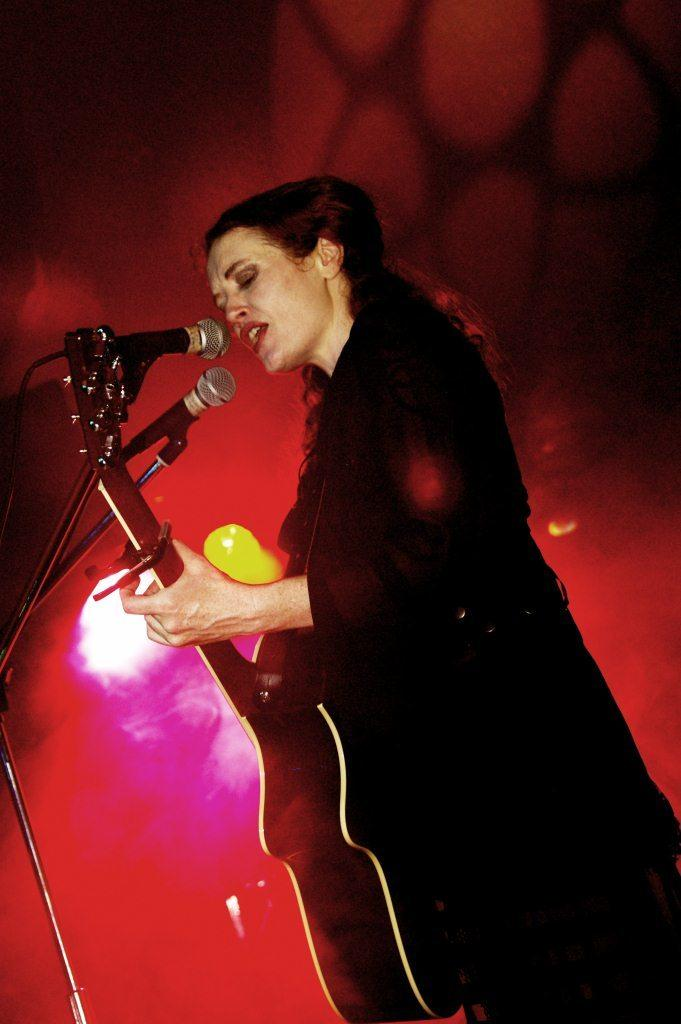Who is the main subject in the image? There is a girl in the image. What is the girl doing in the image? The girl is standing and singing with a microphone. What is the girl holding in her hand? The girl is holding a guitar in her hand. Where is the microphone positioned in relation to the girl? The microphone is in front of her. What type of tin can be seen hanging from the guitar in the image? There is no tin present in the image, and the guitar is not hanging from anything. 